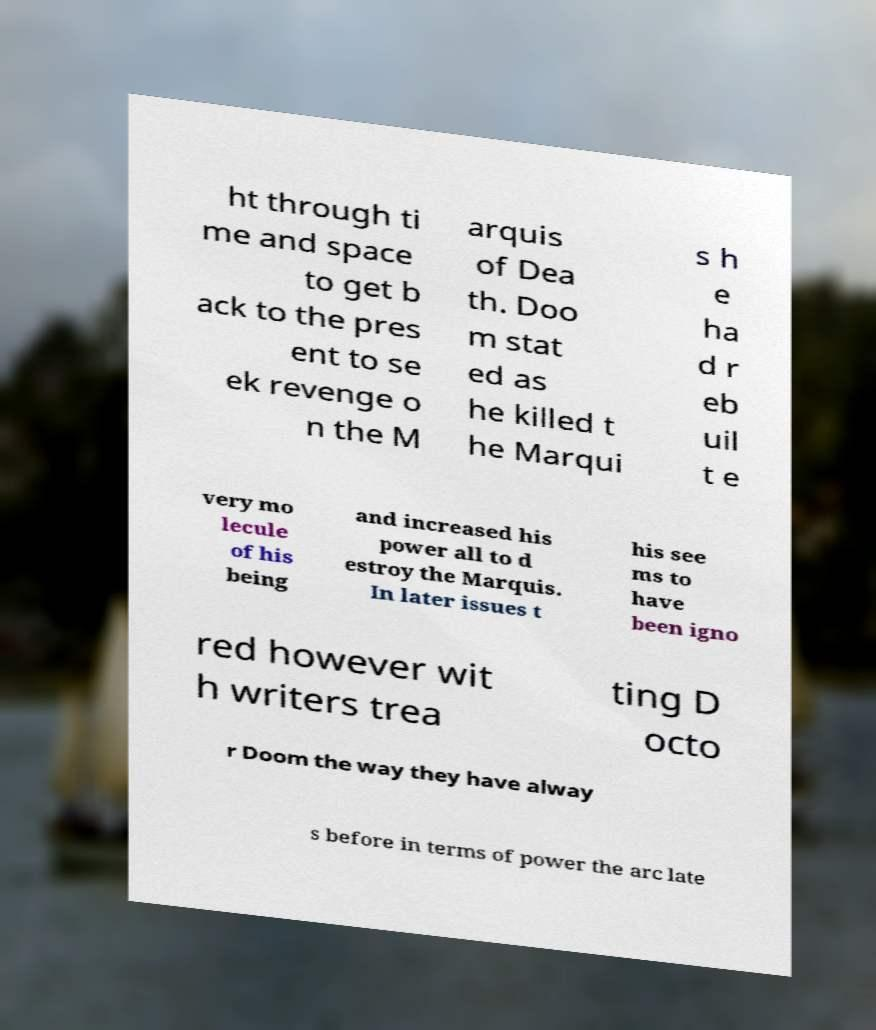Could you assist in decoding the text presented in this image and type it out clearly? ht through ti me and space to get b ack to the pres ent to se ek revenge o n the M arquis of Dea th. Doo m stat ed as he killed t he Marqui s h e ha d r eb uil t e very mo lecule of his being and increased his power all to d estroy the Marquis. In later issues t his see ms to have been igno red however wit h writers trea ting D octo r Doom the way they have alway s before in terms of power the arc late 